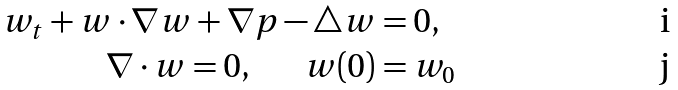Convert formula to latex. <formula><loc_0><loc_0><loc_500><loc_500>w _ { t } + w \cdot \nabla w + \nabla p - \triangle w & = 0 , \\ \nabla \cdot w = 0 , \quad \ \ w ( 0 ) & = w _ { 0 }</formula> 